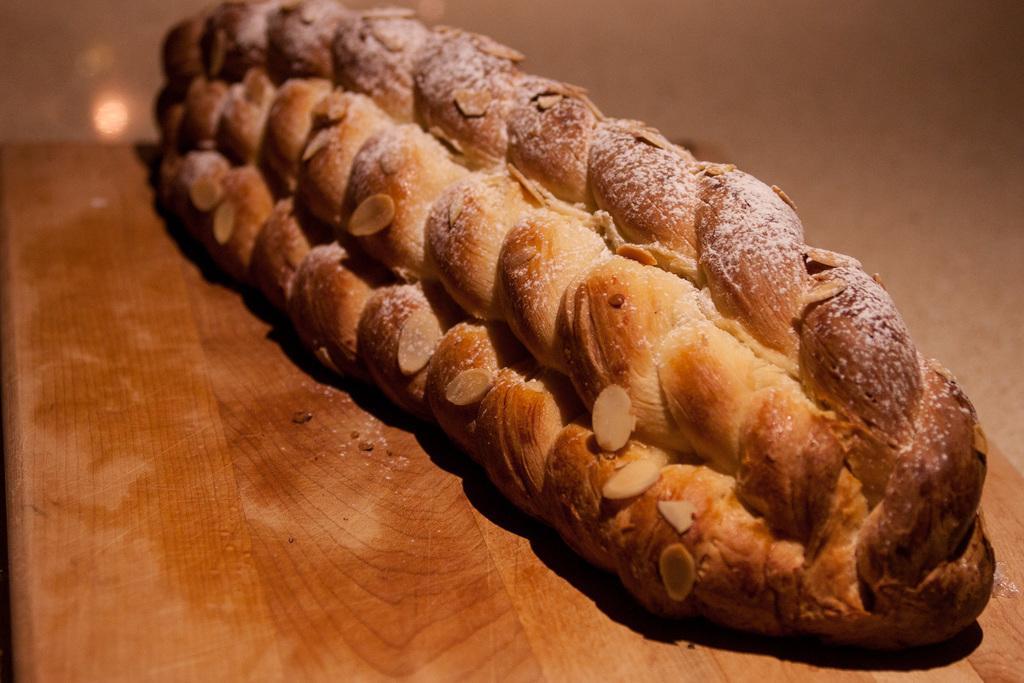In one or two sentences, can you explain what this image depicts? In this picture we can see food item on a wooden platform. 